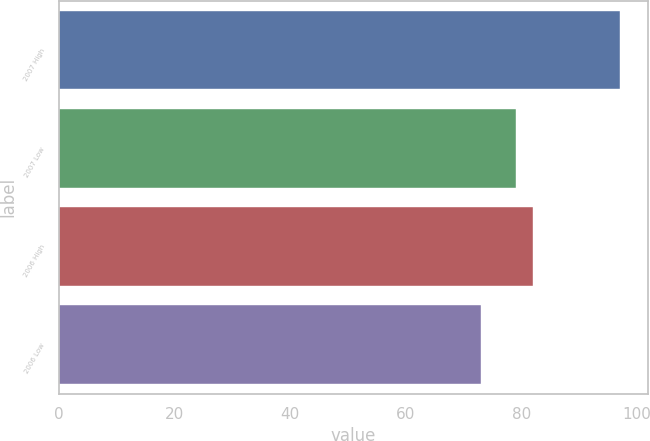Convert chart to OTSL. <chart><loc_0><loc_0><loc_500><loc_500><bar_chart><fcel>2007 High<fcel>2007 Low<fcel>2006 High<fcel>2006 Low<nl><fcel>97<fcel>78.98<fcel>81.95<fcel>73<nl></chart> 